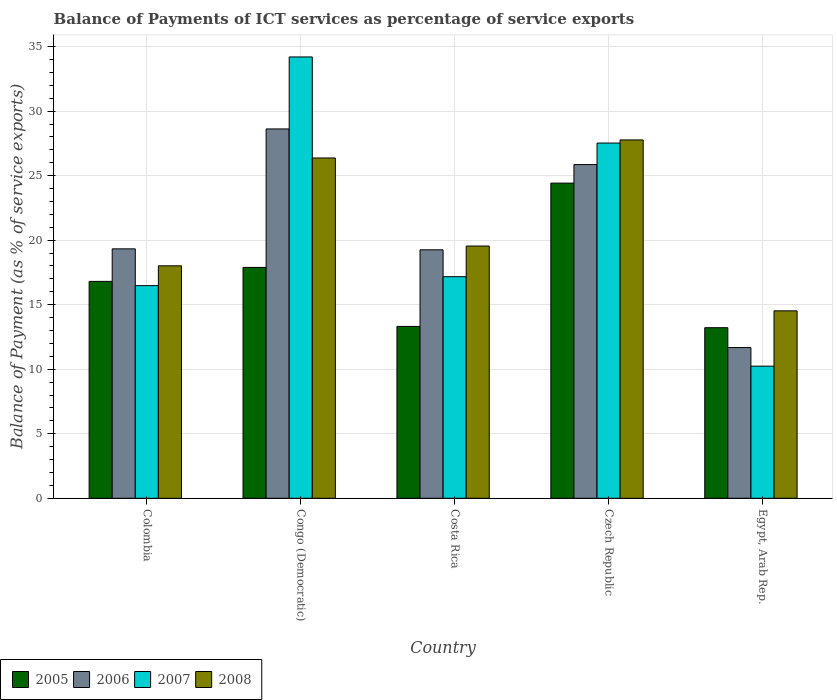How many groups of bars are there?
Offer a terse response. 5. How many bars are there on the 5th tick from the left?
Make the answer very short. 4. How many bars are there on the 1st tick from the right?
Your response must be concise. 4. What is the label of the 4th group of bars from the left?
Provide a succinct answer. Czech Republic. In how many cases, is the number of bars for a given country not equal to the number of legend labels?
Make the answer very short. 0. What is the balance of payments of ICT services in 2005 in Costa Rica?
Offer a very short reply. 13.32. Across all countries, what is the maximum balance of payments of ICT services in 2006?
Provide a short and direct response. 28.62. Across all countries, what is the minimum balance of payments of ICT services in 2006?
Make the answer very short. 11.68. In which country was the balance of payments of ICT services in 2005 maximum?
Your answer should be very brief. Czech Republic. In which country was the balance of payments of ICT services in 2008 minimum?
Make the answer very short. Egypt, Arab Rep. What is the total balance of payments of ICT services in 2007 in the graph?
Your response must be concise. 105.61. What is the difference between the balance of payments of ICT services in 2007 in Colombia and that in Costa Rica?
Provide a succinct answer. -0.69. What is the difference between the balance of payments of ICT services in 2005 in Costa Rica and the balance of payments of ICT services in 2007 in Colombia?
Offer a terse response. -3.16. What is the average balance of payments of ICT services in 2007 per country?
Give a very brief answer. 21.12. What is the difference between the balance of payments of ICT services of/in 2008 and balance of payments of ICT services of/in 2007 in Costa Rica?
Make the answer very short. 2.38. In how many countries, is the balance of payments of ICT services in 2007 greater than 16 %?
Make the answer very short. 4. What is the ratio of the balance of payments of ICT services in 2007 in Colombia to that in Egypt, Arab Rep.?
Provide a short and direct response. 1.61. Is the difference between the balance of payments of ICT services in 2008 in Czech Republic and Egypt, Arab Rep. greater than the difference between the balance of payments of ICT services in 2007 in Czech Republic and Egypt, Arab Rep.?
Ensure brevity in your answer.  No. What is the difference between the highest and the second highest balance of payments of ICT services in 2005?
Ensure brevity in your answer.  6.53. What is the difference between the highest and the lowest balance of payments of ICT services in 2007?
Your answer should be compact. 23.96. Is the sum of the balance of payments of ICT services in 2008 in Colombia and Egypt, Arab Rep. greater than the maximum balance of payments of ICT services in 2006 across all countries?
Give a very brief answer. Yes. What does the 4th bar from the left in Czech Republic represents?
Provide a short and direct response. 2008. What does the 1st bar from the right in Costa Rica represents?
Offer a terse response. 2008. Is it the case that in every country, the sum of the balance of payments of ICT services in 2005 and balance of payments of ICT services in 2007 is greater than the balance of payments of ICT services in 2006?
Give a very brief answer. Yes. How many bars are there?
Offer a very short reply. 20. What is the difference between two consecutive major ticks on the Y-axis?
Offer a terse response. 5. Does the graph contain any zero values?
Offer a very short reply. No. Does the graph contain grids?
Your answer should be compact. Yes. How many legend labels are there?
Your answer should be very brief. 4. How are the legend labels stacked?
Provide a succinct answer. Horizontal. What is the title of the graph?
Offer a terse response. Balance of Payments of ICT services as percentage of service exports. What is the label or title of the Y-axis?
Provide a succinct answer. Balance of Payment (as % of service exports). What is the Balance of Payment (as % of service exports) of 2005 in Colombia?
Provide a succinct answer. 16.81. What is the Balance of Payment (as % of service exports) in 2006 in Colombia?
Offer a terse response. 19.33. What is the Balance of Payment (as % of service exports) in 2007 in Colombia?
Offer a terse response. 16.48. What is the Balance of Payment (as % of service exports) of 2008 in Colombia?
Offer a terse response. 18.01. What is the Balance of Payment (as % of service exports) in 2005 in Congo (Democratic)?
Offer a very short reply. 17.89. What is the Balance of Payment (as % of service exports) in 2006 in Congo (Democratic)?
Offer a very short reply. 28.62. What is the Balance of Payment (as % of service exports) of 2007 in Congo (Democratic)?
Provide a succinct answer. 34.2. What is the Balance of Payment (as % of service exports) of 2008 in Congo (Democratic)?
Your answer should be compact. 26.37. What is the Balance of Payment (as % of service exports) in 2005 in Costa Rica?
Provide a succinct answer. 13.32. What is the Balance of Payment (as % of service exports) of 2006 in Costa Rica?
Make the answer very short. 19.25. What is the Balance of Payment (as % of service exports) of 2007 in Costa Rica?
Ensure brevity in your answer.  17.17. What is the Balance of Payment (as % of service exports) of 2008 in Costa Rica?
Give a very brief answer. 19.55. What is the Balance of Payment (as % of service exports) of 2005 in Czech Republic?
Give a very brief answer. 24.42. What is the Balance of Payment (as % of service exports) of 2006 in Czech Republic?
Ensure brevity in your answer.  25.86. What is the Balance of Payment (as % of service exports) of 2007 in Czech Republic?
Keep it short and to the point. 27.53. What is the Balance of Payment (as % of service exports) in 2008 in Czech Republic?
Provide a short and direct response. 27.77. What is the Balance of Payment (as % of service exports) in 2005 in Egypt, Arab Rep.?
Your answer should be compact. 13.22. What is the Balance of Payment (as % of service exports) in 2006 in Egypt, Arab Rep.?
Give a very brief answer. 11.68. What is the Balance of Payment (as % of service exports) of 2007 in Egypt, Arab Rep.?
Your answer should be very brief. 10.24. What is the Balance of Payment (as % of service exports) of 2008 in Egypt, Arab Rep.?
Provide a short and direct response. 14.52. Across all countries, what is the maximum Balance of Payment (as % of service exports) in 2005?
Provide a short and direct response. 24.42. Across all countries, what is the maximum Balance of Payment (as % of service exports) in 2006?
Offer a very short reply. 28.62. Across all countries, what is the maximum Balance of Payment (as % of service exports) in 2007?
Keep it short and to the point. 34.2. Across all countries, what is the maximum Balance of Payment (as % of service exports) in 2008?
Your answer should be very brief. 27.77. Across all countries, what is the minimum Balance of Payment (as % of service exports) of 2005?
Your answer should be compact. 13.22. Across all countries, what is the minimum Balance of Payment (as % of service exports) in 2006?
Offer a terse response. 11.68. Across all countries, what is the minimum Balance of Payment (as % of service exports) of 2007?
Your answer should be very brief. 10.24. Across all countries, what is the minimum Balance of Payment (as % of service exports) of 2008?
Provide a succinct answer. 14.52. What is the total Balance of Payment (as % of service exports) in 2005 in the graph?
Your answer should be compact. 85.66. What is the total Balance of Payment (as % of service exports) of 2006 in the graph?
Your response must be concise. 104.74. What is the total Balance of Payment (as % of service exports) of 2007 in the graph?
Your answer should be very brief. 105.61. What is the total Balance of Payment (as % of service exports) of 2008 in the graph?
Your response must be concise. 106.22. What is the difference between the Balance of Payment (as % of service exports) in 2005 in Colombia and that in Congo (Democratic)?
Provide a short and direct response. -1.08. What is the difference between the Balance of Payment (as % of service exports) of 2006 in Colombia and that in Congo (Democratic)?
Keep it short and to the point. -9.29. What is the difference between the Balance of Payment (as % of service exports) of 2007 in Colombia and that in Congo (Democratic)?
Provide a succinct answer. -17.72. What is the difference between the Balance of Payment (as % of service exports) of 2008 in Colombia and that in Congo (Democratic)?
Provide a succinct answer. -8.36. What is the difference between the Balance of Payment (as % of service exports) of 2005 in Colombia and that in Costa Rica?
Make the answer very short. 3.49. What is the difference between the Balance of Payment (as % of service exports) in 2006 in Colombia and that in Costa Rica?
Your answer should be very brief. 0.07. What is the difference between the Balance of Payment (as % of service exports) of 2007 in Colombia and that in Costa Rica?
Provide a succinct answer. -0.69. What is the difference between the Balance of Payment (as % of service exports) in 2008 in Colombia and that in Costa Rica?
Provide a succinct answer. -1.53. What is the difference between the Balance of Payment (as % of service exports) in 2005 in Colombia and that in Czech Republic?
Provide a short and direct response. -7.61. What is the difference between the Balance of Payment (as % of service exports) in 2006 in Colombia and that in Czech Republic?
Make the answer very short. -6.53. What is the difference between the Balance of Payment (as % of service exports) in 2007 in Colombia and that in Czech Republic?
Ensure brevity in your answer.  -11.05. What is the difference between the Balance of Payment (as % of service exports) of 2008 in Colombia and that in Czech Republic?
Offer a terse response. -9.76. What is the difference between the Balance of Payment (as % of service exports) in 2005 in Colombia and that in Egypt, Arab Rep.?
Ensure brevity in your answer.  3.59. What is the difference between the Balance of Payment (as % of service exports) in 2006 in Colombia and that in Egypt, Arab Rep.?
Your answer should be compact. 7.65. What is the difference between the Balance of Payment (as % of service exports) in 2007 in Colombia and that in Egypt, Arab Rep.?
Keep it short and to the point. 6.24. What is the difference between the Balance of Payment (as % of service exports) of 2008 in Colombia and that in Egypt, Arab Rep.?
Offer a very short reply. 3.49. What is the difference between the Balance of Payment (as % of service exports) in 2005 in Congo (Democratic) and that in Costa Rica?
Your answer should be compact. 4.57. What is the difference between the Balance of Payment (as % of service exports) of 2006 in Congo (Democratic) and that in Costa Rica?
Make the answer very short. 9.37. What is the difference between the Balance of Payment (as % of service exports) in 2007 in Congo (Democratic) and that in Costa Rica?
Your response must be concise. 17.03. What is the difference between the Balance of Payment (as % of service exports) in 2008 in Congo (Democratic) and that in Costa Rica?
Give a very brief answer. 6.82. What is the difference between the Balance of Payment (as % of service exports) in 2005 in Congo (Democratic) and that in Czech Republic?
Your answer should be compact. -6.53. What is the difference between the Balance of Payment (as % of service exports) of 2006 in Congo (Democratic) and that in Czech Republic?
Give a very brief answer. 2.76. What is the difference between the Balance of Payment (as % of service exports) in 2007 in Congo (Democratic) and that in Czech Republic?
Your answer should be very brief. 6.67. What is the difference between the Balance of Payment (as % of service exports) of 2008 in Congo (Democratic) and that in Czech Republic?
Your answer should be very brief. -1.4. What is the difference between the Balance of Payment (as % of service exports) of 2005 in Congo (Democratic) and that in Egypt, Arab Rep.?
Make the answer very short. 4.67. What is the difference between the Balance of Payment (as % of service exports) in 2006 in Congo (Democratic) and that in Egypt, Arab Rep.?
Provide a succinct answer. 16.94. What is the difference between the Balance of Payment (as % of service exports) of 2007 in Congo (Democratic) and that in Egypt, Arab Rep.?
Your answer should be compact. 23.96. What is the difference between the Balance of Payment (as % of service exports) of 2008 in Congo (Democratic) and that in Egypt, Arab Rep.?
Your response must be concise. 11.85. What is the difference between the Balance of Payment (as % of service exports) in 2005 in Costa Rica and that in Czech Republic?
Provide a short and direct response. -11.1. What is the difference between the Balance of Payment (as % of service exports) of 2006 in Costa Rica and that in Czech Republic?
Your response must be concise. -6.6. What is the difference between the Balance of Payment (as % of service exports) in 2007 in Costa Rica and that in Czech Republic?
Offer a terse response. -10.36. What is the difference between the Balance of Payment (as % of service exports) of 2008 in Costa Rica and that in Czech Republic?
Keep it short and to the point. -8.22. What is the difference between the Balance of Payment (as % of service exports) in 2005 in Costa Rica and that in Egypt, Arab Rep.?
Provide a short and direct response. 0.1. What is the difference between the Balance of Payment (as % of service exports) of 2006 in Costa Rica and that in Egypt, Arab Rep.?
Your response must be concise. 7.57. What is the difference between the Balance of Payment (as % of service exports) in 2007 in Costa Rica and that in Egypt, Arab Rep.?
Offer a very short reply. 6.93. What is the difference between the Balance of Payment (as % of service exports) of 2008 in Costa Rica and that in Egypt, Arab Rep.?
Give a very brief answer. 5.02. What is the difference between the Balance of Payment (as % of service exports) in 2005 in Czech Republic and that in Egypt, Arab Rep.?
Offer a terse response. 11.2. What is the difference between the Balance of Payment (as % of service exports) in 2006 in Czech Republic and that in Egypt, Arab Rep.?
Your response must be concise. 14.18. What is the difference between the Balance of Payment (as % of service exports) of 2007 in Czech Republic and that in Egypt, Arab Rep.?
Your answer should be very brief. 17.29. What is the difference between the Balance of Payment (as % of service exports) in 2008 in Czech Republic and that in Egypt, Arab Rep.?
Your answer should be compact. 13.24. What is the difference between the Balance of Payment (as % of service exports) in 2005 in Colombia and the Balance of Payment (as % of service exports) in 2006 in Congo (Democratic)?
Keep it short and to the point. -11.81. What is the difference between the Balance of Payment (as % of service exports) in 2005 in Colombia and the Balance of Payment (as % of service exports) in 2007 in Congo (Democratic)?
Your answer should be very brief. -17.39. What is the difference between the Balance of Payment (as % of service exports) of 2005 in Colombia and the Balance of Payment (as % of service exports) of 2008 in Congo (Democratic)?
Ensure brevity in your answer.  -9.56. What is the difference between the Balance of Payment (as % of service exports) in 2006 in Colombia and the Balance of Payment (as % of service exports) in 2007 in Congo (Democratic)?
Your response must be concise. -14.87. What is the difference between the Balance of Payment (as % of service exports) of 2006 in Colombia and the Balance of Payment (as % of service exports) of 2008 in Congo (Democratic)?
Provide a succinct answer. -7.04. What is the difference between the Balance of Payment (as % of service exports) of 2007 in Colombia and the Balance of Payment (as % of service exports) of 2008 in Congo (Democratic)?
Ensure brevity in your answer.  -9.89. What is the difference between the Balance of Payment (as % of service exports) in 2005 in Colombia and the Balance of Payment (as % of service exports) in 2006 in Costa Rica?
Offer a very short reply. -2.45. What is the difference between the Balance of Payment (as % of service exports) of 2005 in Colombia and the Balance of Payment (as % of service exports) of 2007 in Costa Rica?
Ensure brevity in your answer.  -0.36. What is the difference between the Balance of Payment (as % of service exports) of 2005 in Colombia and the Balance of Payment (as % of service exports) of 2008 in Costa Rica?
Ensure brevity in your answer.  -2.74. What is the difference between the Balance of Payment (as % of service exports) of 2006 in Colombia and the Balance of Payment (as % of service exports) of 2007 in Costa Rica?
Give a very brief answer. 2.16. What is the difference between the Balance of Payment (as % of service exports) of 2006 in Colombia and the Balance of Payment (as % of service exports) of 2008 in Costa Rica?
Your answer should be compact. -0.22. What is the difference between the Balance of Payment (as % of service exports) of 2007 in Colombia and the Balance of Payment (as % of service exports) of 2008 in Costa Rica?
Make the answer very short. -3.07. What is the difference between the Balance of Payment (as % of service exports) in 2005 in Colombia and the Balance of Payment (as % of service exports) in 2006 in Czech Republic?
Give a very brief answer. -9.05. What is the difference between the Balance of Payment (as % of service exports) in 2005 in Colombia and the Balance of Payment (as % of service exports) in 2007 in Czech Republic?
Keep it short and to the point. -10.72. What is the difference between the Balance of Payment (as % of service exports) in 2005 in Colombia and the Balance of Payment (as % of service exports) in 2008 in Czech Republic?
Give a very brief answer. -10.96. What is the difference between the Balance of Payment (as % of service exports) of 2006 in Colombia and the Balance of Payment (as % of service exports) of 2007 in Czech Republic?
Provide a short and direct response. -8.2. What is the difference between the Balance of Payment (as % of service exports) of 2006 in Colombia and the Balance of Payment (as % of service exports) of 2008 in Czech Republic?
Offer a terse response. -8.44. What is the difference between the Balance of Payment (as % of service exports) in 2007 in Colombia and the Balance of Payment (as % of service exports) in 2008 in Czech Republic?
Keep it short and to the point. -11.29. What is the difference between the Balance of Payment (as % of service exports) in 2005 in Colombia and the Balance of Payment (as % of service exports) in 2006 in Egypt, Arab Rep.?
Ensure brevity in your answer.  5.13. What is the difference between the Balance of Payment (as % of service exports) of 2005 in Colombia and the Balance of Payment (as % of service exports) of 2007 in Egypt, Arab Rep.?
Your answer should be very brief. 6.57. What is the difference between the Balance of Payment (as % of service exports) of 2005 in Colombia and the Balance of Payment (as % of service exports) of 2008 in Egypt, Arab Rep.?
Provide a short and direct response. 2.28. What is the difference between the Balance of Payment (as % of service exports) in 2006 in Colombia and the Balance of Payment (as % of service exports) in 2007 in Egypt, Arab Rep.?
Your response must be concise. 9.09. What is the difference between the Balance of Payment (as % of service exports) of 2006 in Colombia and the Balance of Payment (as % of service exports) of 2008 in Egypt, Arab Rep.?
Give a very brief answer. 4.8. What is the difference between the Balance of Payment (as % of service exports) in 2007 in Colombia and the Balance of Payment (as % of service exports) in 2008 in Egypt, Arab Rep.?
Keep it short and to the point. 1.95. What is the difference between the Balance of Payment (as % of service exports) of 2005 in Congo (Democratic) and the Balance of Payment (as % of service exports) of 2006 in Costa Rica?
Your answer should be compact. -1.36. What is the difference between the Balance of Payment (as % of service exports) of 2005 in Congo (Democratic) and the Balance of Payment (as % of service exports) of 2007 in Costa Rica?
Offer a very short reply. 0.72. What is the difference between the Balance of Payment (as % of service exports) in 2005 in Congo (Democratic) and the Balance of Payment (as % of service exports) in 2008 in Costa Rica?
Your answer should be compact. -1.66. What is the difference between the Balance of Payment (as % of service exports) in 2006 in Congo (Democratic) and the Balance of Payment (as % of service exports) in 2007 in Costa Rica?
Offer a terse response. 11.45. What is the difference between the Balance of Payment (as % of service exports) of 2006 in Congo (Democratic) and the Balance of Payment (as % of service exports) of 2008 in Costa Rica?
Your response must be concise. 9.07. What is the difference between the Balance of Payment (as % of service exports) of 2007 in Congo (Democratic) and the Balance of Payment (as % of service exports) of 2008 in Costa Rica?
Your answer should be compact. 14.65. What is the difference between the Balance of Payment (as % of service exports) of 2005 in Congo (Democratic) and the Balance of Payment (as % of service exports) of 2006 in Czech Republic?
Make the answer very short. -7.97. What is the difference between the Balance of Payment (as % of service exports) in 2005 in Congo (Democratic) and the Balance of Payment (as % of service exports) in 2007 in Czech Republic?
Provide a succinct answer. -9.64. What is the difference between the Balance of Payment (as % of service exports) in 2005 in Congo (Democratic) and the Balance of Payment (as % of service exports) in 2008 in Czech Republic?
Your answer should be compact. -9.88. What is the difference between the Balance of Payment (as % of service exports) in 2006 in Congo (Democratic) and the Balance of Payment (as % of service exports) in 2007 in Czech Republic?
Give a very brief answer. 1.09. What is the difference between the Balance of Payment (as % of service exports) of 2006 in Congo (Democratic) and the Balance of Payment (as % of service exports) of 2008 in Czech Republic?
Your response must be concise. 0.85. What is the difference between the Balance of Payment (as % of service exports) in 2007 in Congo (Democratic) and the Balance of Payment (as % of service exports) in 2008 in Czech Republic?
Provide a succinct answer. 6.43. What is the difference between the Balance of Payment (as % of service exports) in 2005 in Congo (Democratic) and the Balance of Payment (as % of service exports) in 2006 in Egypt, Arab Rep.?
Keep it short and to the point. 6.21. What is the difference between the Balance of Payment (as % of service exports) in 2005 in Congo (Democratic) and the Balance of Payment (as % of service exports) in 2007 in Egypt, Arab Rep.?
Provide a succinct answer. 7.65. What is the difference between the Balance of Payment (as % of service exports) in 2005 in Congo (Democratic) and the Balance of Payment (as % of service exports) in 2008 in Egypt, Arab Rep.?
Make the answer very short. 3.37. What is the difference between the Balance of Payment (as % of service exports) of 2006 in Congo (Democratic) and the Balance of Payment (as % of service exports) of 2007 in Egypt, Arab Rep.?
Offer a very short reply. 18.38. What is the difference between the Balance of Payment (as % of service exports) of 2006 in Congo (Democratic) and the Balance of Payment (as % of service exports) of 2008 in Egypt, Arab Rep.?
Give a very brief answer. 14.1. What is the difference between the Balance of Payment (as % of service exports) of 2007 in Congo (Democratic) and the Balance of Payment (as % of service exports) of 2008 in Egypt, Arab Rep.?
Provide a short and direct response. 19.68. What is the difference between the Balance of Payment (as % of service exports) in 2005 in Costa Rica and the Balance of Payment (as % of service exports) in 2006 in Czech Republic?
Give a very brief answer. -12.54. What is the difference between the Balance of Payment (as % of service exports) of 2005 in Costa Rica and the Balance of Payment (as % of service exports) of 2007 in Czech Republic?
Give a very brief answer. -14.21. What is the difference between the Balance of Payment (as % of service exports) of 2005 in Costa Rica and the Balance of Payment (as % of service exports) of 2008 in Czech Republic?
Keep it short and to the point. -14.45. What is the difference between the Balance of Payment (as % of service exports) of 2006 in Costa Rica and the Balance of Payment (as % of service exports) of 2007 in Czech Republic?
Offer a terse response. -8.27. What is the difference between the Balance of Payment (as % of service exports) of 2006 in Costa Rica and the Balance of Payment (as % of service exports) of 2008 in Czech Republic?
Give a very brief answer. -8.51. What is the difference between the Balance of Payment (as % of service exports) in 2007 in Costa Rica and the Balance of Payment (as % of service exports) in 2008 in Czech Republic?
Your answer should be compact. -10.6. What is the difference between the Balance of Payment (as % of service exports) of 2005 in Costa Rica and the Balance of Payment (as % of service exports) of 2006 in Egypt, Arab Rep.?
Give a very brief answer. 1.64. What is the difference between the Balance of Payment (as % of service exports) of 2005 in Costa Rica and the Balance of Payment (as % of service exports) of 2007 in Egypt, Arab Rep.?
Make the answer very short. 3.08. What is the difference between the Balance of Payment (as % of service exports) in 2005 in Costa Rica and the Balance of Payment (as % of service exports) in 2008 in Egypt, Arab Rep.?
Your answer should be very brief. -1.21. What is the difference between the Balance of Payment (as % of service exports) of 2006 in Costa Rica and the Balance of Payment (as % of service exports) of 2007 in Egypt, Arab Rep.?
Offer a very short reply. 9.02. What is the difference between the Balance of Payment (as % of service exports) of 2006 in Costa Rica and the Balance of Payment (as % of service exports) of 2008 in Egypt, Arab Rep.?
Offer a very short reply. 4.73. What is the difference between the Balance of Payment (as % of service exports) in 2007 in Costa Rica and the Balance of Payment (as % of service exports) in 2008 in Egypt, Arab Rep.?
Give a very brief answer. 2.65. What is the difference between the Balance of Payment (as % of service exports) in 2005 in Czech Republic and the Balance of Payment (as % of service exports) in 2006 in Egypt, Arab Rep.?
Ensure brevity in your answer.  12.74. What is the difference between the Balance of Payment (as % of service exports) of 2005 in Czech Republic and the Balance of Payment (as % of service exports) of 2007 in Egypt, Arab Rep.?
Offer a terse response. 14.18. What is the difference between the Balance of Payment (as % of service exports) of 2005 in Czech Republic and the Balance of Payment (as % of service exports) of 2008 in Egypt, Arab Rep.?
Ensure brevity in your answer.  9.9. What is the difference between the Balance of Payment (as % of service exports) of 2006 in Czech Republic and the Balance of Payment (as % of service exports) of 2007 in Egypt, Arab Rep.?
Offer a very short reply. 15.62. What is the difference between the Balance of Payment (as % of service exports) in 2006 in Czech Republic and the Balance of Payment (as % of service exports) in 2008 in Egypt, Arab Rep.?
Make the answer very short. 11.34. What is the difference between the Balance of Payment (as % of service exports) in 2007 in Czech Republic and the Balance of Payment (as % of service exports) in 2008 in Egypt, Arab Rep.?
Your answer should be compact. 13. What is the average Balance of Payment (as % of service exports) in 2005 per country?
Your response must be concise. 17.13. What is the average Balance of Payment (as % of service exports) of 2006 per country?
Make the answer very short. 20.95. What is the average Balance of Payment (as % of service exports) of 2007 per country?
Your answer should be very brief. 21.12. What is the average Balance of Payment (as % of service exports) of 2008 per country?
Ensure brevity in your answer.  21.24. What is the difference between the Balance of Payment (as % of service exports) in 2005 and Balance of Payment (as % of service exports) in 2006 in Colombia?
Ensure brevity in your answer.  -2.52. What is the difference between the Balance of Payment (as % of service exports) of 2005 and Balance of Payment (as % of service exports) of 2007 in Colombia?
Offer a terse response. 0.33. What is the difference between the Balance of Payment (as % of service exports) in 2005 and Balance of Payment (as % of service exports) in 2008 in Colombia?
Offer a terse response. -1.21. What is the difference between the Balance of Payment (as % of service exports) of 2006 and Balance of Payment (as % of service exports) of 2007 in Colombia?
Offer a terse response. 2.85. What is the difference between the Balance of Payment (as % of service exports) of 2006 and Balance of Payment (as % of service exports) of 2008 in Colombia?
Give a very brief answer. 1.32. What is the difference between the Balance of Payment (as % of service exports) of 2007 and Balance of Payment (as % of service exports) of 2008 in Colombia?
Your answer should be very brief. -1.54. What is the difference between the Balance of Payment (as % of service exports) of 2005 and Balance of Payment (as % of service exports) of 2006 in Congo (Democratic)?
Make the answer very short. -10.73. What is the difference between the Balance of Payment (as % of service exports) of 2005 and Balance of Payment (as % of service exports) of 2007 in Congo (Democratic)?
Make the answer very short. -16.31. What is the difference between the Balance of Payment (as % of service exports) in 2005 and Balance of Payment (as % of service exports) in 2008 in Congo (Democratic)?
Provide a succinct answer. -8.48. What is the difference between the Balance of Payment (as % of service exports) in 2006 and Balance of Payment (as % of service exports) in 2007 in Congo (Democratic)?
Ensure brevity in your answer.  -5.58. What is the difference between the Balance of Payment (as % of service exports) in 2006 and Balance of Payment (as % of service exports) in 2008 in Congo (Democratic)?
Your answer should be compact. 2.25. What is the difference between the Balance of Payment (as % of service exports) of 2007 and Balance of Payment (as % of service exports) of 2008 in Congo (Democratic)?
Provide a short and direct response. 7.83. What is the difference between the Balance of Payment (as % of service exports) in 2005 and Balance of Payment (as % of service exports) in 2006 in Costa Rica?
Give a very brief answer. -5.94. What is the difference between the Balance of Payment (as % of service exports) of 2005 and Balance of Payment (as % of service exports) of 2007 in Costa Rica?
Give a very brief answer. -3.85. What is the difference between the Balance of Payment (as % of service exports) of 2005 and Balance of Payment (as % of service exports) of 2008 in Costa Rica?
Provide a short and direct response. -6.23. What is the difference between the Balance of Payment (as % of service exports) of 2006 and Balance of Payment (as % of service exports) of 2007 in Costa Rica?
Keep it short and to the point. 2.08. What is the difference between the Balance of Payment (as % of service exports) of 2006 and Balance of Payment (as % of service exports) of 2008 in Costa Rica?
Your answer should be very brief. -0.29. What is the difference between the Balance of Payment (as % of service exports) of 2007 and Balance of Payment (as % of service exports) of 2008 in Costa Rica?
Your response must be concise. -2.38. What is the difference between the Balance of Payment (as % of service exports) of 2005 and Balance of Payment (as % of service exports) of 2006 in Czech Republic?
Ensure brevity in your answer.  -1.44. What is the difference between the Balance of Payment (as % of service exports) in 2005 and Balance of Payment (as % of service exports) in 2007 in Czech Republic?
Make the answer very short. -3.1. What is the difference between the Balance of Payment (as % of service exports) in 2005 and Balance of Payment (as % of service exports) in 2008 in Czech Republic?
Make the answer very short. -3.35. What is the difference between the Balance of Payment (as % of service exports) of 2006 and Balance of Payment (as % of service exports) of 2007 in Czech Republic?
Your answer should be very brief. -1.67. What is the difference between the Balance of Payment (as % of service exports) of 2006 and Balance of Payment (as % of service exports) of 2008 in Czech Republic?
Your answer should be very brief. -1.91. What is the difference between the Balance of Payment (as % of service exports) of 2007 and Balance of Payment (as % of service exports) of 2008 in Czech Republic?
Provide a succinct answer. -0.24. What is the difference between the Balance of Payment (as % of service exports) in 2005 and Balance of Payment (as % of service exports) in 2006 in Egypt, Arab Rep.?
Make the answer very short. 1.54. What is the difference between the Balance of Payment (as % of service exports) of 2005 and Balance of Payment (as % of service exports) of 2007 in Egypt, Arab Rep.?
Your answer should be compact. 2.98. What is the difference between the Balance of Payment (as % of service exports) of 2005 and Balance of Payment (as % of service exports) of 2008 in Egypt, Arab Rep.?
Your answer should be very brief. -1.3. What is the difference between the Balance of Payment (as % of service exports) of 2006 and Balance of Payment (as % of service exports) of 2007 in Egypt, Arab Rep.?
Your answer should be compact. 1.44. What is the difference between the Balance of Payment (as % of service exports) in 2006 and Balance of Payment (as % of service exports) in 2008 in Egypt, Arab Rep.?
Provide a succinct answer. -2.84. What is the difference between the Balance of Payment (as % of service exports) of 2007 and Balance of Payment (as % of service exports) of 2008 in Egypt, Arab Rep.?
Your answer should be very brief. -4.29. What is the ratio of the Balance of Payment (as % of service exports) in 2005 in Colombia to that in Congo (Democratic)?
Ensure brevity in your answer.  0.94. What is the ratio of the Balance of Payment (as % of service exports) of 2006 in Colombia to that in Congo (Democratic)?
Offer a terse response. 0.68. What is the ratio of the Balance of Payment (as % of service exports) of 2007 in Colombia to that in Congo (Democratic)?
Your answer should be very brief. 0.48. What is the ratio of the Balance of Payment (as % of service exports) in 2008 in Colombia to that in Congo (Democratic)?
Offer a terse response. 0.68. What is the ratio of the Balance of Payment (as % of service exports) of 2005 in Colombia to that in Costa Rica?
Give a very brief answer. 1.26. What is the ratio of the Balance of Payment (as % of service exports) of 2007 in Colombia to that in Costa Rica?
Your answer should be compact. 0.96. What is the ratio of the Balance of Payment (as % of service exports) in 2008 in Colombia to that in Costa Rica?
Offer a terse response. 0.92. What is the ratio of the Balance of Payment (as % of service exports) in 2005 in Colombia to that in Czech Republic?
Offer a terse response. 0.69. What is the ratio of the Balance of Payment (as % of service exports) of 2006 in Colombia to that in Czech Republic?
Your answer should be compact. 0.75. What is the ratio of the Balance of Payment (as % of service exports) in 2007 in Colombia to that in Czech Republic?
Provide a short and direct response. 0.6. What is the ratio of the Balance of Payment (as % of service exports) in 2008 in Colombia to that in Czech Republic?
Provide a short and direct response. 0.65. What is the ratio of the Balance of Payment (as % of service exports) of 2005 in Colombia to that in Egypt, Arab Rep.?
Give a very brief answer. 1.27. What is the ratio of the Balance of Payment (as % of service exports) in 2006 in Colombia to that in Egypt, Arab Rep.?
Offer a terse response. 1.65. What is the ratio of the Balance of Payment (as % of service exports) of 2007 in Colombia to that in Egypt, Arab Rep.?
Your response must be concise. 1.61. What is the ratio of the Balance of Payment (as % of service exports) of 2008 in Colombia to that in Egypt, Arab Rep.?
Your answer should be compact. 1.24. What is the ratio of the Balance of Payment (as % of service exports) of 2005 in Congo (Democratic) to that in Costa Rica?
Offer a terse response. 1.34. What is the ratio of the Balance of Payment (as % of service exports) in 2006 in Congo (Democratic) to that in Costa Rica?
Provide a succinct answer. 1.49. What is the ratio of the Balance of Payment (as % of service exports) of 2007 in Congo (Democratic) to that in Costa Rica?
Provide a succinct answer. 1.99. What is the ratio of the Balance of Payment (as % of service exports) of 2008 in Congo (Democratic) to that in Costa Rica?
Your response must be concise. 1.35. What is the ratio of the Balance of Payment (as % of service exports) of 2005 in Congo (Democratic) to that in Czech Republic?
Make the answer very short. 0.73. What is the ratio of the Balance of Payment (as % of service exports) of 2006 in Congo (Democratic) to that in Czech Republic?
Offer a very short reply. 1.11. What is the ratio of the Balance of Payment (as % of service exports) in 2007 in Congo (Democratic) to that in Czech Republic?
Offer a very short reply. 1.24. What is the ratio of the Balance of Payment (as % of service exports) of 2008 in Congo (Democratic) to that in Czech Republic?
Offer a terse response. 0.95. What is the ratio of the Balance of Payment (as % of service exports) in 2005 in Congo (Democratic) to that in Egypt, Arab Rep.?
Your answer should be compact. 1.35. What is the ratio of the Balance of Payment (as % of service exports) of 2006 in Congo (Democratic) to that in Egypt, Arab Rep.?
Provide a succinct answer. 2.45. What is the ratio of the Balance of Payment (as % of service exports) in 2007 in Congo (Democratic) to that in Egypt, Arab Rep.?
Offer a terse response. 3.34. What is the ratio of the Balance of Payment (as % of service exports) in 2008 in Congo (Democratic) to that in Egypt, Arab Rep.?
Your answer should be very brief. 1.82. What is the ratio of the Balance of Payment (as % of service exports) in 2005 in Costa Rica to that in Czech Republic?
Offer a terse response. 0.55. What is the ratio of the Balance of Payment (as % of service exports) in 2006 in Costa Rica to that in Czech Republic?
Provide a succinct answer. 0.74. What is the ratio of the Balance of Payment (as % of service exports) of 2007 in Costa Rica to that in Czech Republic?
Offer a very short reply. 0.62. What is the ratio of the Balance of Payment (as % of service exports) in 2008 in Costa Rica to that in Czech Republic?
Your answer should be very brief. 0.7. What is the ratio of the Balance of Payment (as % of service exports) of 2005 in Costa Rica to that in Egypt, Arab Rep.?
Give a very brief answer. 1.01. What is the ratio of the Balance of Payment (as % of service exports) of 2006 in Costa Rica to that in Egypt, Arab Rep.?
Offer a very short reply. 1.65. What is the ratio of the Balance of Payment (as % of service exports) of 2007 in Costa Rica to that in Egypt, Arab Rep.?
Your answer should be compact. 1.68. What is the ratio of the Balance of Payment (as % of service exports) of 2008 in Costa Rica to that in Egypt, Arab Rep.?
Your answer should be very brief. 1.35. What is the ratio of the Balance of Payment (as % of service exports) in 2005 in Czech Republic to that in Egypt, Arab Rep.?
Offer a very short reply. 1.85. What is the ratio of the Balance of Payment (as % of service exports) of 2006 in Czech Republic to that in Egypt, Arab Rep.?
Make the answer very short. 2.21. What is the ratio of the Balance of Payment (as % of service exports) in 2007 in Czech Republic to that in Egypt, Arab Rep.?
Make the answer very short. 2.69. What is the ratio of the Balance of Payment (as % of service exports) in 2008 in Czech Republic to that in Egypt, Arab Rep.?
Your answer should be compact. 1.91. What is the difference between the highest and the second highest Balance of Payment (as % of service exports) of 2005?
Provide a succinct answer. 6.53. What is the difference between the highest and the second highest Balance of Payment (as % of service exports) of 2006?
Provide a succinct answer. 2.76. What is the difference between the highest and the second highest Balance of Payment (as % of service exports) in 2007?
Your answer should be compact. 6.67. What is the difference between the highest and the second highest Balance of Payment (as % of service exports) in 2008?
Ensure brevity in your answer.  1.4. What is the difference between the highest and the lowest Balance of Payment (as % of service exports) of 2005?
Your response must be concise. 11.2. What is the difference between the highest and the lowest Balance of Payment (as % of service exports) of 2006?
Offer a very short reply. 16.94. What is the difference between the highest and the lowest Balance of Payment (as % of service exports) of 2007?
Ensure brevity in your answer.  23.96. What is the difference between the highest and the lowest Balance of Payment (as % of service exports) in 2008?
Keep it short and to the point. 13.24. 